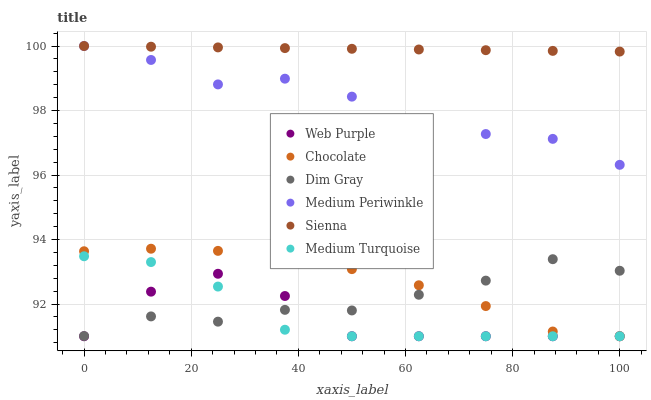Does Web Purple have the minimum area under the curve?
Answer yes or no. Yes. Does Sienna have the maximum area under the curve?
Answer yes or no. Yes. Does Medium Periwinkle have the minimum area under the curve?
Answer yes or no. No. Does Medium Periwinkle have the maximum area under the curve?
Answer yes or no. No. Is Sienna the smoothest?
Answer yes or no. Yes. Is Web Purple the roughest?
Answer yes or no. Yes. Is Medium Periwinkle the smoothest?
Answer yes or no. No. Is Medium Periwinkle the roughest?
Answer yes or no. No. Does Chocolate have the lowest value?
Answer yes or no. Yes. Does Medium Periwinkle have the lowest value?
Answer yes or no. No. Does Sienna have the highest value?
Answer yes or no. Yes. Does Chocolate have the highest value?
Answer yes or no. No. Is Dim Gray less than Medium Periwinkle?
Answer yes or no. Yes. Is Sienna greater than Dim Gray?
Answer yes or no. Yes. Does Chocolate intersect Medium Turquoise?
Answer yes or no. Yes. Is Chocolate less than Medium Turquoise?
Answer yes or no. No. Is Chocolate greater than Medium Turquoise?
Answer yes or no. No. Does Dim Gray intersect Medium Periwinkle?
Answer yes or no. No. 